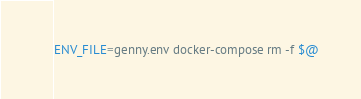<code> <loc_0><loc_0><loc_500><loc_500><_Bash_>ENV_FILE=genny.env docker-compose rm -f $@

</code> 